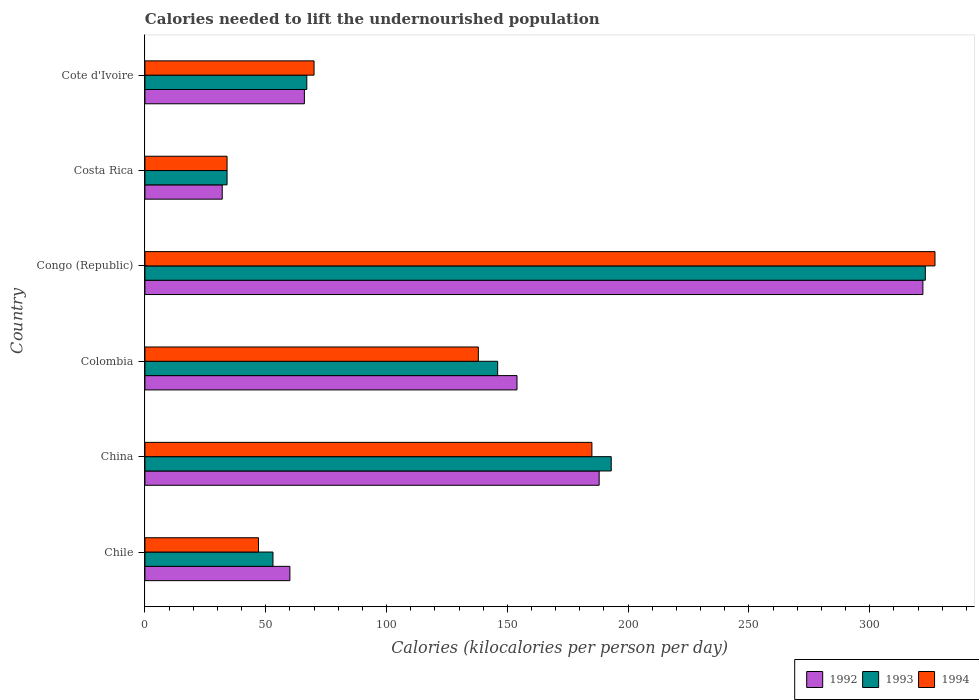How many different coloured bars are there?
Ensure brevity in your answer.  3. How many groups of bars are there?
Your answer should be very brief. 6. How many bars are there on the 6th tick from the top?
Offer a very short reply. 3. What is the label of the 3rd group of bars from the top?
Your answer should be compact. Congo (Republic). In how many cases, is the number of bars for a given country not equal to the number of legend labels?
Offer a very short reply. 0. Across all countries, what is the maximum total calories needed to lift the undernourished population in 1993?
Give a very brief answer. 323. In which country was the total calories needed to lift the undernourished population in 1992 maximum?
Your answer should be very brief. Congo (Republic). What is the total total calories needed to lift the undernourished population in 1993 in the graph?
Offer a terse response. 816. What is the difference between the total calories needed to lift the undernourished population in 1994 in China and that in Cote d'Ivoire?
Give a very brief answer. 115. What is the average total calories needed to lift the undernourished population in 1993 per country?
Your answer should be very brief. 136. What is the difference between the total calories needed to lift the undernourished population in 1994 and total calories needed to lift the undernourished population in 1993 in Colombia?
Give a very brief answer. -8. In how many countries, is the total calories needed to lift the undernourished population in 1994 greater than 190 kilocalories?
Offer a very short reply. 1. What is the ratio of the total calories needed to lift the undernourished population in 1992 in Costa Rica to that in Cote d'Ivoire?
Make the answer very short. 0.48. Is the difference between the total calories needed to lift the undernourished population in 1994 in Costa Rica and Cote d'Ivoire greater than the difference between the total calories needed to lift the undernourished population in 1993 in Costa Rica and Cote d'Ivoire?
Give a very brief answer. No. What is the difference between the highest and the second highest total calories needed to lift the undernourished population in 1994?
Your answer should be very brief. 142. What is the difference between the highest and the lowest total calories needed to lift the undernourished population in 1994?
Your answer should be compact. 293. In how many countries, is the total calories needed to lift the undernourished population in 1993 greater than the average total calories needed to lift the undernourished population in 1993 taken over all countries?
Make the answer very short. 3. What does the 2nd bar from the top in Costa Rica represents?
Provide a short and direct response. 1993. What does the 3rd bar from the bottom in China represents?
Your answer should be very brief. 1994. How many countries are there in the graph?
Keep it short and to the point. 6. What is the difference between two consecutive major ticks on the X-axis?
Ensure brevity in your answer.  50. Are the values on the major ticks of X-axis written in scientific E-notation?
Provide a succinct answer. No. Does the graph contain any zero values?
Your response must be concise. No. Does the graph contain grids?
Your answer should be very brief. No. Where does the legend appear in the graph?
Give a very brief answer. Bottom right. How many legend labels are there?
Ensure brevity in your answer.  3. How are the legend labels stacked?
Ensure brevity in your answer.  Horizontal. What is the title of the graph?
Your answer should be compact. Calories needed to lift the undernourished population. What is the label or title of the X-axis?
Ensure brevity in your answer.  Calories (kilocalories per person per day). What is the label or title of the Y-axis?
Keep it short and to the point. Country. What is the Calories (kilocalories per person per day) in 1992 in China?
Make the answer very short. 188. What is the Calories (kilocalories per person per day) of 1993 in China?
Ensure brevity in your answer.  193. What is the Calories (kilocalories per person per day) of 1994 in China?
Make the answer very short. 185. What is the Calories (kilocalories per person per day) of 1992 in Colombia?
Your answer should be compact. 154. What is the Calories (kilocalories per person per day) of 1993 in Colombia?
Give a very brief answer. 146. What is the Calories (kilocalories per person per day) of 1994 in Colombia?
Ensure brevity in your answer.  138. What is the Calories (kilocalories per person per day) in 1992 in Congo (Republic)?
Provide a short and direct response. 322. What is the Calories (kilocalories per person per day) in 1993 in Congo (Republic)?
Your answer should be compact. 323. What is the Calories (kilocalories per person per day) in 1994 in Congo (Republic)?
Provide a short and direct response. 327. What is the Calories (kilocalories per person per day) in 1992 in Costa Rica?
Provide a short and direct response. 32. What is the Calories (kilocalories per person per day) of 1993 in Costa Rica?
Provide a short and direct response. 34. What is the Calories (kilocalories per person per day) of 1992 in Cote d'Ivoire?
Offer a very short reply. 66. What is the Calories (kilocalories per person per day) of 1993 in Cote d'Ivoire?
Make the answer very short. 67. Across all countries, what is the maximum Calories (kilocalories per person per day) of 1992?
Give a very brief answer. 322. Across all countries, what is the maximum Calories (kilocalories per person per day) of 1993?
Your answer should be very brief. 323. Across all countries, what is the maximum Calories (kilocalories per person per day) in 1994?
Your answer should be compact. 327. Across all countries, what is the minimum Calories (kilocalories per person per day) in 1994?
Make the answer very short. 34. What is the total Calories (kilocalories per person per day) of 1992 in the graph?
Your response must be concise. 822. What is the total Calories (kilocalories per person per day) of 1993 in the graph?
Your response must be concise. 816. What is the total Calories (kilocalories per person per day) in 1994 in the graph?
Your answer should be very brief. 801. What is the difference between the Calories (kilocalories per person per day) in 1992 in Chile and that in China?
Provide a succinct answer. -128. What is the difference between the Calories (kilocalories per person per day) in 1993 in Chile and that in China?
Keep it short and to the point. -140. What is the difference between the Calories (kilocalories per person per day) of 1994 in Chile and that in China?
Make the answer very short. -138. What is the difference between the Calories (kilocalories per person per day) in 1992 in Chile and that in Colombia?
Keep it short and to the point. -94. What is the difference between the Calories (kilocalories per person per day) of 1993 in Chile and that in Colombia?
Keep it short and to the point. -93. What is the difference between the Calories (kilocalories per person per day) of 1994 in Chile and that in Colombia?
Offer a terse response. -91. What is the difference between the Calories (kilocalories per person per day) of 1992 in Chile and that in Congo (Republic)?
Offer a terse response. -262. What is the difference between the Calories (kilocalories per person per day) in 1993 in Chile and that in Congo (Republic)?
Give a very brief answer. -270. What is the difference between the Calories (kilocalories per person per day) in 1994 in Chile and that in Congo (Republic)?
Give a very brief answer. -280. What is the difference between the Calories (kilocalories per person per day) in 1993 in Chile and that in Costa Rica?
Provide a succinct answer. 19. What is the difference between the Calories (kilocalories per person per day) of 1994 in Chile and that in Costa Rica?
Your response must be concise. 13. What is the difference between the Calories (kilocalories per person per day) in 1992 in Chile and that in Cote d'Ivoire?
Your response must be concise. -6. What is the difference between the Calories (kilocalories per person per day) of 1993 in Chile and that in Cote d'Ivoire?
Your answer should be very brief. -14. What is the difference between the Calories (kilocalories per person per day) in 1994 in Chile and that in Cote d'Ivoire?
Offer a terse response. -23. What is the difference between the Calories (kilocalories per person per day) of 1992 in China and that in Colombia?
Your response must be concise. 34. What is the difference between the Calories (kilocalories per person per day) in 1993 in China and that in Colombia?
Provide a short and direct response. 47. What is the difference between the Calories (kilocalories per person per day) in 1992 in China and that in Congo (Republic)?
Provide a short and direct response. -134. What is the difference between the Calories (kilocalories per person per day) in 1993 in China and that in Congo (Republic)?
Offer a terse response. -130. What is the difference between the Calories (kilocalories per person per day) in 1994 in China and that in Congo (Republic)?
Provide a succinct answer. -142. What is the difference between the Calories (kilocalories per person per day) in 1992 in China and that in Costa Rica?
Give a very brief answer. 156. What is the difference between the Calories (kilocalories per person per day) of 1993 in China and that in Costa Rica?
Your answer should be compact. 159. What is the difference between the Calories (kilocalories per person per day) of 1994 in China and that in Costa Rica?
Provide a succinct answer. 151. What is the difference between the Calories (kilocalories per person per day) of 1992 in China and that in Cote d'Ivoire?
Offer a very short reply. 122. What is the difference between the Calories (kilocalories per person per day) in 1993 in China and that in Cote d'Ivoire?
Your response must be concise. 126. What is the difference between the Calories (kilocalories per person per day) in 1994 in China and that in Cote d'Ivoire?
Offer a terse response. 115. What is the difference between the Calories (kilocalories per person per day) of 1992 in Colombia and that in Congo (Republic)?
Your response must be concise. -168. What is the difference between the Calories (kilocalories per person per day) in 1993 in Colombia and that in Congo (Republic)?
Provide a short and direct response. -177. What is the difference between the Calories (kilocalories per person per day) of 1994 in Colombia and that in Congo (Republic)?
Your response must be concise. -189. What is the difference between the Calories (kilocalories per person per day) in 1992 in Colombia and that in Costa Rica?
Make the answer very short. 122. What is the difference between the Calories (kilocalories per person per day) in 1993 in Colombia and that in Costa Rica?
Provide a succinct answer. 112. What is the difference between the Calories (kilocalories per person per day) of 1994 in Colombia and that in Costa Rica?
Your answer should be compact. 104. What is the difference between the Calories (kilocalories per person per day) of 1993 in Colombia and that in Cote d'Ivoire?
Your response must be concise. 79. What is the difference between the Calories (kilocalories per person per day) of 1992 in Congo (Republic) and that in Costa Rica?
Offer a terse response. 290. What is the difference between the Calories (kilocalories per person per day) in 1993 in Congo (Republic) and that in Costa Rica?
Ensure brevity in your answer.  289. What is the difference between the Calories (kilocalories per person per day) in 1994 in Congo (Republic) and that in Costa Rica?
Your answer should be compact. 293. What is the difference between the Calories (kilocalories per person per day) in 1992 in Congo (Republic) and that in Cote d'Ivoire?
Ensure brevity in your answer.  256. What is the difference between the Calories (kilocalories per person per day) in 1993 in Congo (Republic) and that in Cote d'Ivoire?
Your response must be concise. 256. What is the difference between the Calories (kilocalories per person per day) in 1994 in Congo (Republic) and that in Cote d'Ivoire?
Your answer should be very brief. 257. What is the difference between the Calories (kilocalories per person per day) in 1992 in Costa Rica and that in Cote d'Ivoire?
Offer a terse response. -34. What is the difference between the Calories (kilocalories per person per day) in 1993 in Costa Rica and that in Cote d'Ivoire?
Provide a short and direct response. -33. What is the difference between the Calories (kilocalories per person per day) in 1994 in Costa Rica and that in Cote d'Ivoire?
Your response must be concise. -36. What is the difference between the Calories (kilocalories per person per day) of 1992 in Chile and the Calories (kilocalories per person per day) of 1993 in China?
Your answer should be compact. -133. What is the difference between the Calories (kilocalories per person per day) in 1992 in Chile and the Calories (kilocalories per person per day) in 1994 in China?
Make the answer very short. -125. What is the difference between the Calories (kilocalories per person per day) in 1993 in Chile and the Calories (kilocalories per person per day) in 1994 in China?
Give a very brief answer. -132. What is the difference between the Calories (kilocalories per person per day) of 1992 in Chile and the Calories (kilocalories per person per day) of 1993 in Colombia?
Offer a very short reply. -86. What is the difference between the Calories (kilocalories per person per day) of 1992 in Chile and the Calories (kilocalories per person per day) of 1994 in Colombia?
Your answer should be compact. -78. What is the difference between the Calories (kilocalories per person per day) of 1993 in Chile and the Calories (kilocalories per person per day) of 1994 in Colombia?
Your response must be concise. -85. What is the difference between the Calories (kilocalories per person per day) of 1992 in Chile and the Calories (kilocalories per person per day) of 1993 in Congo (Republic)?
Keep it short and to the point. -263. What is the difference between the Calories (kilocalories per person per day) in 1992 in Chile and the Calories (kilocalories per person per day) in 1994 in Congo (Republic)?
Your response must be concise. -267. What is the difference between the Calories (kilocalories per person per day) of 1993 in Chile and the Calories (kilocalories per person per day) of 1994 in Congo (Republic)?
Offer a very short reply. -274. What is the difference between the Calories (kilocalories per person per day) in 1992 in Chile and the Calories (kilocalories per person per day) in 1994 in Cote d'Ivoire?
Offer a terse response. -10. What is the difference between the Calories (kilocalories per person per day) in 1993 in Chile and the Calories (kilocalories per person per day) in 1994 in Cote d'Ivoire?
Your response must be concise. -17. What is the difference between the Calories (kilocalories per person per day) of 1992 in China and the Calories (kilocalories per person per day) of 1993 in Colombia?
Your answer should be very brief. 42. What is the difference between the Calories (kilocalories per person per day) in 1992 in China and the Calories (kilocalories per person per day) in 1994 in Colombia?
Ensure brevity in your answer.  50. What is the difference between the Calories (kilocalories per person per day) of 1993 in China and the Calories (kilocalories per person per day) of 1994 in Colombia?
Keep it short and to the point. 55. What is the difference between the Calories (kilocalories per person per day) of 1992 in China and the Calories (kilocalories per person per day) of 1993 in Congo (Republic)?
Offer a terse response. -135. What is the difference between the Calories (kilocalories per person per day) of 1992 in China and the Calories (kilocalories per person per day) of 1994 in Congo (Republic)?
Ensure brevity in your answer.  -139. What is the difference between the Calories (kilocalories per person per day) in 1993 in China and the Calories (kilocalories per person per day) in 1994 in Congo (Republic)?
Give a very brief answer. -134. What is the difference between the Calories (kilocalories per person per day) of 1992 in China and the Calories (kilocalories per person per day) of 1993 in Costa Rica?
Make the answer very short. 154. What is the difference between the Calories (kilocalories per person per day) in 1992 in China and the Calories (kilocalories per person per day) in 1994 in Costa Rica?
Your answer should be compact. 154. What is the difference between the Calories (kilocalories per person per day) of 1993 in China and the Calories (kilocalories per person per day) of 1994 in Costa Rica?
Ensure brevity in your answer.  159. What is the difference between the Calories (kilocalories per person per day) of 1992 in China and the Calories (kilocalories per person per day) of 1993 in Cote d'Ivoire?
Provide a succinct answer. 121. What is the difference between the Calories (kilocalories per person per day) in 1992 in China and the Calories (kilocalories per person per day) in 1994 in Cote d'Ivoire?
Make the answer very short. 118. What is the difference between the Calories (kilocalories per person per day) in 1993 in China and the Calories (kilocalories per person per day) in 1994 in Cote d'Ivoire?
Provide a short and direct response. 123. What is the difference between the Calories (kilocalories per person per day) of 1992 in Colombia and the Calories (kilocalories per person per day) of 1993 in Congo (Republic)?
Make the answer very short. -169. What is the difference between the Calories (kilocalories per person per day) of 1992 in Colombia and the Calories (kilocalories per person per day) of 1994 in Congo (Republic)?
Your answer should be very brief. -173. What is the difference between the Calories (kilocalories per person per day) in 1993 in Colombia and the Calories (kilocalories per person per day) in 1994 in Congo (Republic)?
Offer a very short reply. -181. What is the difference between the Calories (kilocalories per person per day) in 1992 in Colombia and the Calories (kilocalories per person per day) in 1993 in Costa Rica?
Offer a terse response. 120. What is the difference between the Calories (kilocalories per person per day) of 1992 in Colombia and the Calories (kilocalories per person per day) of 1994 in Costa Rica?
Your response must be concise. 120. What is the difference between the Calories (kilocalories per person per day) in 1993 in Colombia and the Calories (kilocalories per person per day) in 1994 in Costa Rica?
Provide a short and direct response. 112. What is the difference between the Calories (kilocalories per person per day) in 1992 in Colombia and the Calories (kilocalories per person per day) in 1994 in Cote d'Ivoire?
Make the answer very short. 84. What is the difference between the Calories (kilocalories per person per day) of 1993 in Colombia and the Calories (kilocalories per person per day) of 1994 in Cote d'Ivoire?
Make the answer very short. 76. What is the difference between the Calories (kilocalories per person per day) in 1992 in Congo (Republic) and the Calories (kilocalories per person per day) in 1993 in Costa Rica?
Make the answer very short. 288. What is the difference between the Calories (kilocalories per person per day) of 1992 in Congo (Republic) and the Calories (kilocalories per person per day) of 1994 in Costa Rica?
Ensure brevity in your answer.  288. What is the difference between the Calories (kilocalories per person per day) of 1993 in Congo (Republic) and the Calories (kilocalories per person per day) of 1994 in Costa Rica?
Your response must be concise. 289. What is the difference between the Calories (kilocalories per person per day) in 1992 in Congo (Republic) and the Calories (kilocalories per person per day) in 1993 in Cote d'Ivoire?
Your answer should be very brief. 255. What is the difference between the Calories (kilocalories per person per day) of 1992 in Congo (Republic) and the Calories (kilocalories per person per day) of 1994 in Cote d'Ivoire?
Keep it short and to the point. 252. What is the difference between the Calories (kilocalories per person per day) in 1993 in Congo (Republic) and the Calories (kilocalories per person per day) in 1994 in Cote d'Ivoire?
Make the answer very short. 253. What is the difference between the Calories (kilocalories per person per day) of 1992 in Costa Rica and the Calories (kilocalories per person per day) of 1993 in Cote d'Ivoire?
Offer a terse response. -35. What is the difference between the Calories (kilocalories per person per day) in 1992 in Costa Rica and the Calories (kilocalories per person per day) in 1994 in Cote d'Ivoire?
Ensure brevity in your answer.  -38. What is the difference between the Calories (kilocalories per person per day) of 1993 in Costa Rica and the Calories (kilocalories per person per day) of 1994 in Cote d'Ivoire?
Your answer should be very brief. -36. What is the average Calories (kilocalories per person per day) of 1992 per country?
Ensure brevity in your answer.  137. What is the average Calories (kilocalories per person per day) in 1993 per country?
Provide a short and direct response. 136. What is the average Calories (kilocalories per person per day) of 1994 per country?
Offer a very short reply. 133.5. What is the difference between the Calories (kilocalories per person per day) in 1992 and Calories (kilocalories per person per day) in 1993 in Chile?
Make the answer very short. 7. What is the difference between the Calories (kilocalories per person per day) in 1992 and Calories (kilocalories per person per day) in 1994 in Chile?
Make the answer very short. 13. What is the difference between the Calories (kilocalories per person per day) in 1992 and Calories (kilocalories per person per day) in 1993 in China?
Give a very brief answer. -5. What is the difference between the Calories (kilocalories per person per day) in 1992 and Calories (kilocalories per person per day) in 1994 in China?
Your response must be concise. 3. What is the difference between the Calories (kilocalories per person per day) of 1992 and Calories (kilocalories per person per day) of 1993 in Colombia?
Keep it short and to the point. 8. What is the difference between the Calories (kilocalories per person per day) of 1993 and Calories (kilocalories per person per day) of 1994 in Colombia?
Provide a short and direct response. 8. What is the difference between the Calories (kilocalories per person per day) of 1992 and Calories (kilocalories per person per day) of 1993 in Congo (Republic)?
Your answer should be compact. -1. What is the difference between the Calories (kilocalories per person per day) in 1992 and Calories (kilocalories per person per day) in 1993 in Costa Rica?
Offer a terse response. -2. What is the difference between the Calories (kilocalories per person per day) of 1993 and Calories (kilocalories per person per day) of 1994 in Costa Rica?
Give a very brief answer. 0. What is the difference between the Calories (kilocalories per person per day) in 1992 and Calories (kilocalories per person per day) in 1993 in Cote d'Ivoire?
Give a very brief answer. -1. What is the ratio of the Calories (kilocalories per person per day) in 1992 in Chile to that in China?
Provide a succinct answer. 0.32. What is the ratio of the Calories (kilocalories per person per day) in 1993 in Chile to that in China?
Offer a very short reply. 0.27. What is the ratio of the Calories (kilocalories per person per day) in 1994 in Chile to that in China?
Keep it short and to the point. 0.25. What is the ratio of the Calories (kilocalories per person per day) of 1992 in Chile to that in Colombia?
Offer a terse response. 0.39. What is the ratio of the Calories (kilocalories per person per day) of 1993 in Chile to that in Colombia?
Your answer should be compact. 0.36. What is the ratio of the Calories (kilocalories per person per day) of 1994 in Chile to that in Colombia?
Your answer should be very brief. 0.34. What is the ratio of the Calories (kilocalories per person per day) of 1992 in Chile to that in Congo (Republic)?
Your answer should be compact. 0.19. What is the ratio of the Calories (kilocalories per person per day) of 1993 in Chile to that in Congo (Republic)?
Your response must be concise. 0.16. What is the ratio of the Calories (kilocalories per person per day) in 1994 in Chile to that in Congo (Republic)?
Your response must be concise. 0.14. What is the ratio of the Calories (kilocalories per person per day) in 1992 in Chile to that in Costa Rica?
Provide a short and direct response. 1.88. What is the ratio of the Calories (kilocalories per person per day) in 1993 in Chile to that in Costa Rica?
Offer a terse response. 1.56. What is the ratio of the Calories (kilocalories per person per day) of 1994 in Chile to that in Costa Rica?
Keep it short and to the point. 1.38. What is the ratio of the Calories (kilocalories per person per day) in 1993 in Chile to that in Cote d'Ivoire?
Provide a succinct answer. 0.79. What is the ratio of the Calories (kilocalories per person per day) in 1994 in Chile to that in Cote d'Ivoire?
Your answer should be compact. 0.67. What is the ratio of the Calories (kilocalories per person per day) in 1992 in China to that in Colombia?
Provide a short and direct response. 1.22. What is the ratio of the Calories (kilocalories per person per day) of 1993 in China to that in Colombia?
Offer a terse response. 1.32. What is the ratio of the Calories (kilocalories per person per day) of 1994 in China to that in Colombia?
Ensure brevity in your answer.  1.34. What is the ratio of the Calories (kilocalories per person per day) of 1992 in China to that in Congo (Republic)?
Offer a terse response. 0.58. What is the ratio of the Calories (kilocalories per person per day) of 1993 in China to that in Congo (Republic)?
Give a very brief answer. 0.6. What is the ratio of the Calories (kilocalories per person per day) of 1994 in China to that in Congo (Republic)?
Your answer should be very brief. 0.57. What is the ratio of the Calories (kilocalories per person per day) in 1992 in China to that in Costa Rica?
Ensure brevity in your answer.  5.88. What is the ratio of the Calories (kilocalories per person per day) of 1993 in China to that in Costa Rica?
Your answer should be very brief. 5.68. What is the ratio of the Calories (kilocalories per person per day) of 1994 in China to that in Costa Rica?
Your answer should be very brief. 5.44. What is the ratio of the Calories (kilocalories per person per day) in 1992 in China to that in Cote d'Ivoire?
Offer a terse response. 2.85. What is the ratio of the Calories (kilocalories per person per day) in 1993 in China to that in Cote d'Ivoire?
Give a very brief answer. 2.88. What is the ratio of the Calories (kilocalories per person per day) in 1994 in China to that in Cote d'Ivoire?
Give a very brief answer. 2.64. What is the ratio of the Calories (kilocalories per person per day) in 1992 in Colombia to that in Congo (Republic)?
Make the answer very short. 0.48. What is the ratio of the Calories (kilocalories per person per day) in 1993 in Colombia to that in Congo (Republic)?
Provide a short and direct response. 0.45. What is the ratio of the Calories (kilocalories per person per day) in 1994 in Colombia to that in Congo (Republic)?
Your answer should be very brief. 0.42. What is the ratio of the Calories (kilocalories per person per day) of 1992 in Colombia to that in Costa Rica?
Provide a short and direct response. 4.81. What is the ratio of the Calories (kilocalories per person per day) of 1993 in Colombia to that in Costa Rica?
Ensure brevity in your answer.  4.29. What is the ratio of the Calories (kilocalories per person per day) of 1994 in Colombia to that in Costa Rica?
Your response must be concise. 4.06. What is the ratio of the Calories (kilocalories per person per day) of 1992 in Colombia to that in Cote d'Ivoire?
Your answer should be very brief. 2.33. What is the ratio of the Calories (kilocalories per person per day) of 1993 in Colombia to that in Cote d'Ivoire?
Provide a succinct answer. 2.18. What is the ratio of the Calories (kilocalories per person per day) of 1994 in Colombia to that in Cote d'Ivoire?
Your answer should be compact. 1.97. What is the ratio of the Calories (kilocalories per person per day) of 1992 in Congo (Republic) to that in Costa Rica?
Offer a terse response. 10.06. What is the ratio of the Calories (kilocalories per person per day) in 1993 in Congo (Republic) to that in Costa Rica?
Your answer should be compact. 9.5. What is the ratio of the Calories (kilocalories per person per day) in 1994 in Congo (Republic) to that in Costa Rica?
Keep it short and to the point. 9.62. What is the ratio of the Calories (kilocalories per person per day) in 1992 in Congo (Republic) to that in Cote d'Ivoire?
Give a very brief answer. 4.88. What is the ratio of the Calories (kilocalories per person per day) of 1993 in Congo (Republic) to that in Cote d'Ivoire?
Keep it short and to the point. 4.82. What is the ratio of the Calories (kilocalories per person per day) of 1994 in Congo (Republic) to that in Cote d'Ivoire?
Provide a succinct answer. 4.67. What is the ratio of the Calories (kilocalories per person per day) of 1992 in Costa Rica to that in Cote d'Ivoire?
Offer a terse response. 0.48. What is the ratio of the Calories (kilocalories per person per day) of 1993 in Costa Rica to that in Cote d'Ivoire?
Provide a succinct answer. 0.51. What is the ratio of the Calories (kilocalories per person per day) of 1994 in Costa Rica to that in Cote d'Ivoire?
Give a very brief answer. 0.49. What is the difference between the highest and the second highest Calories (kilocalories per person per day) in 1992?
Offer a terse response. 134. What is the difference between the highest and the second highest Calories (kilocalories per person per day) in 1993?
Keep it short and to the point. 130. What is the difference between the highest and the second highest Calories (kilocalories per person per day) of 1994?
Offer a terse response. 142. What is the difference between the highest and the lowest Calories (kilocalories per person per day) of 1992?
Your answer should be compact. 290. What is the difference between the highest and the lowest Calories (kilocalories per person per day) of 1993?
Your answer should be very brief. 289. What is the difference between the highest and the lowest Calories (kilocalories per person per day) of 1994?
Make the answer very short. 293. 